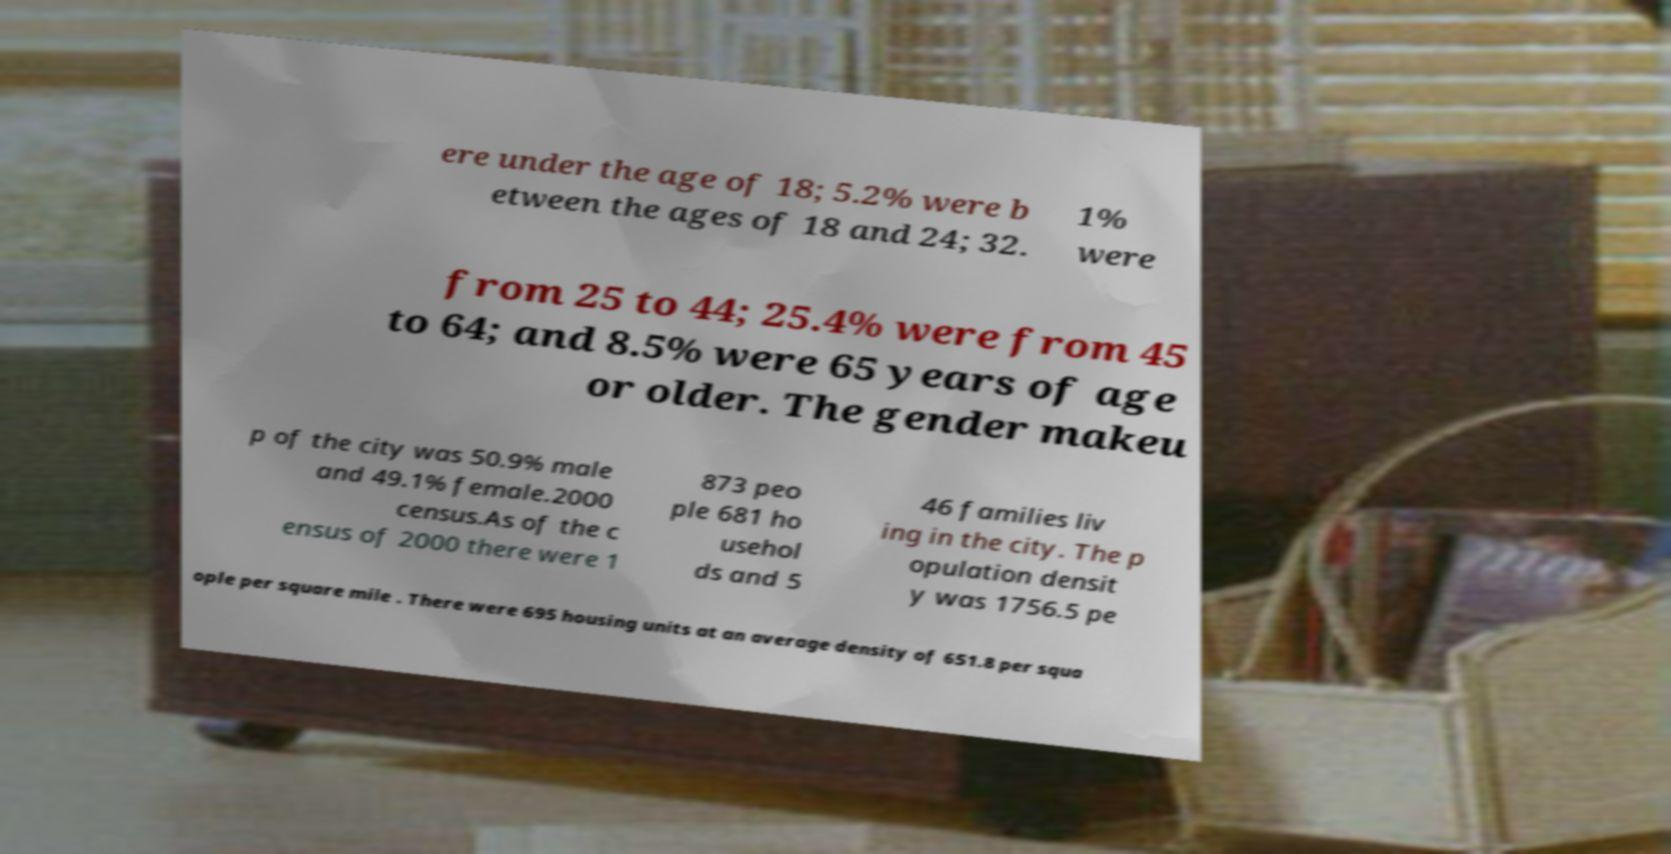Could you assist in decoding the text presented in this image and type it out clearly? ere under the age of 18; 5.2% were b etween the ages of 18 and 24; 32. 1% were from 25 to 44; 25.4% were from 45 to 64; and 8.5% were 65 years of age or older. The gender makeu p of the city was 50.9% male and 49.1% female.2000 census.As of the c ensus of 2000 there were 1 873 peo ple 681 ho usehol ds and 5 46 families liv ing in the city. The p opulation densit y was 1756.5 pe ople per square mile . There were 695 housing units at an average density of 651.8 per squa 